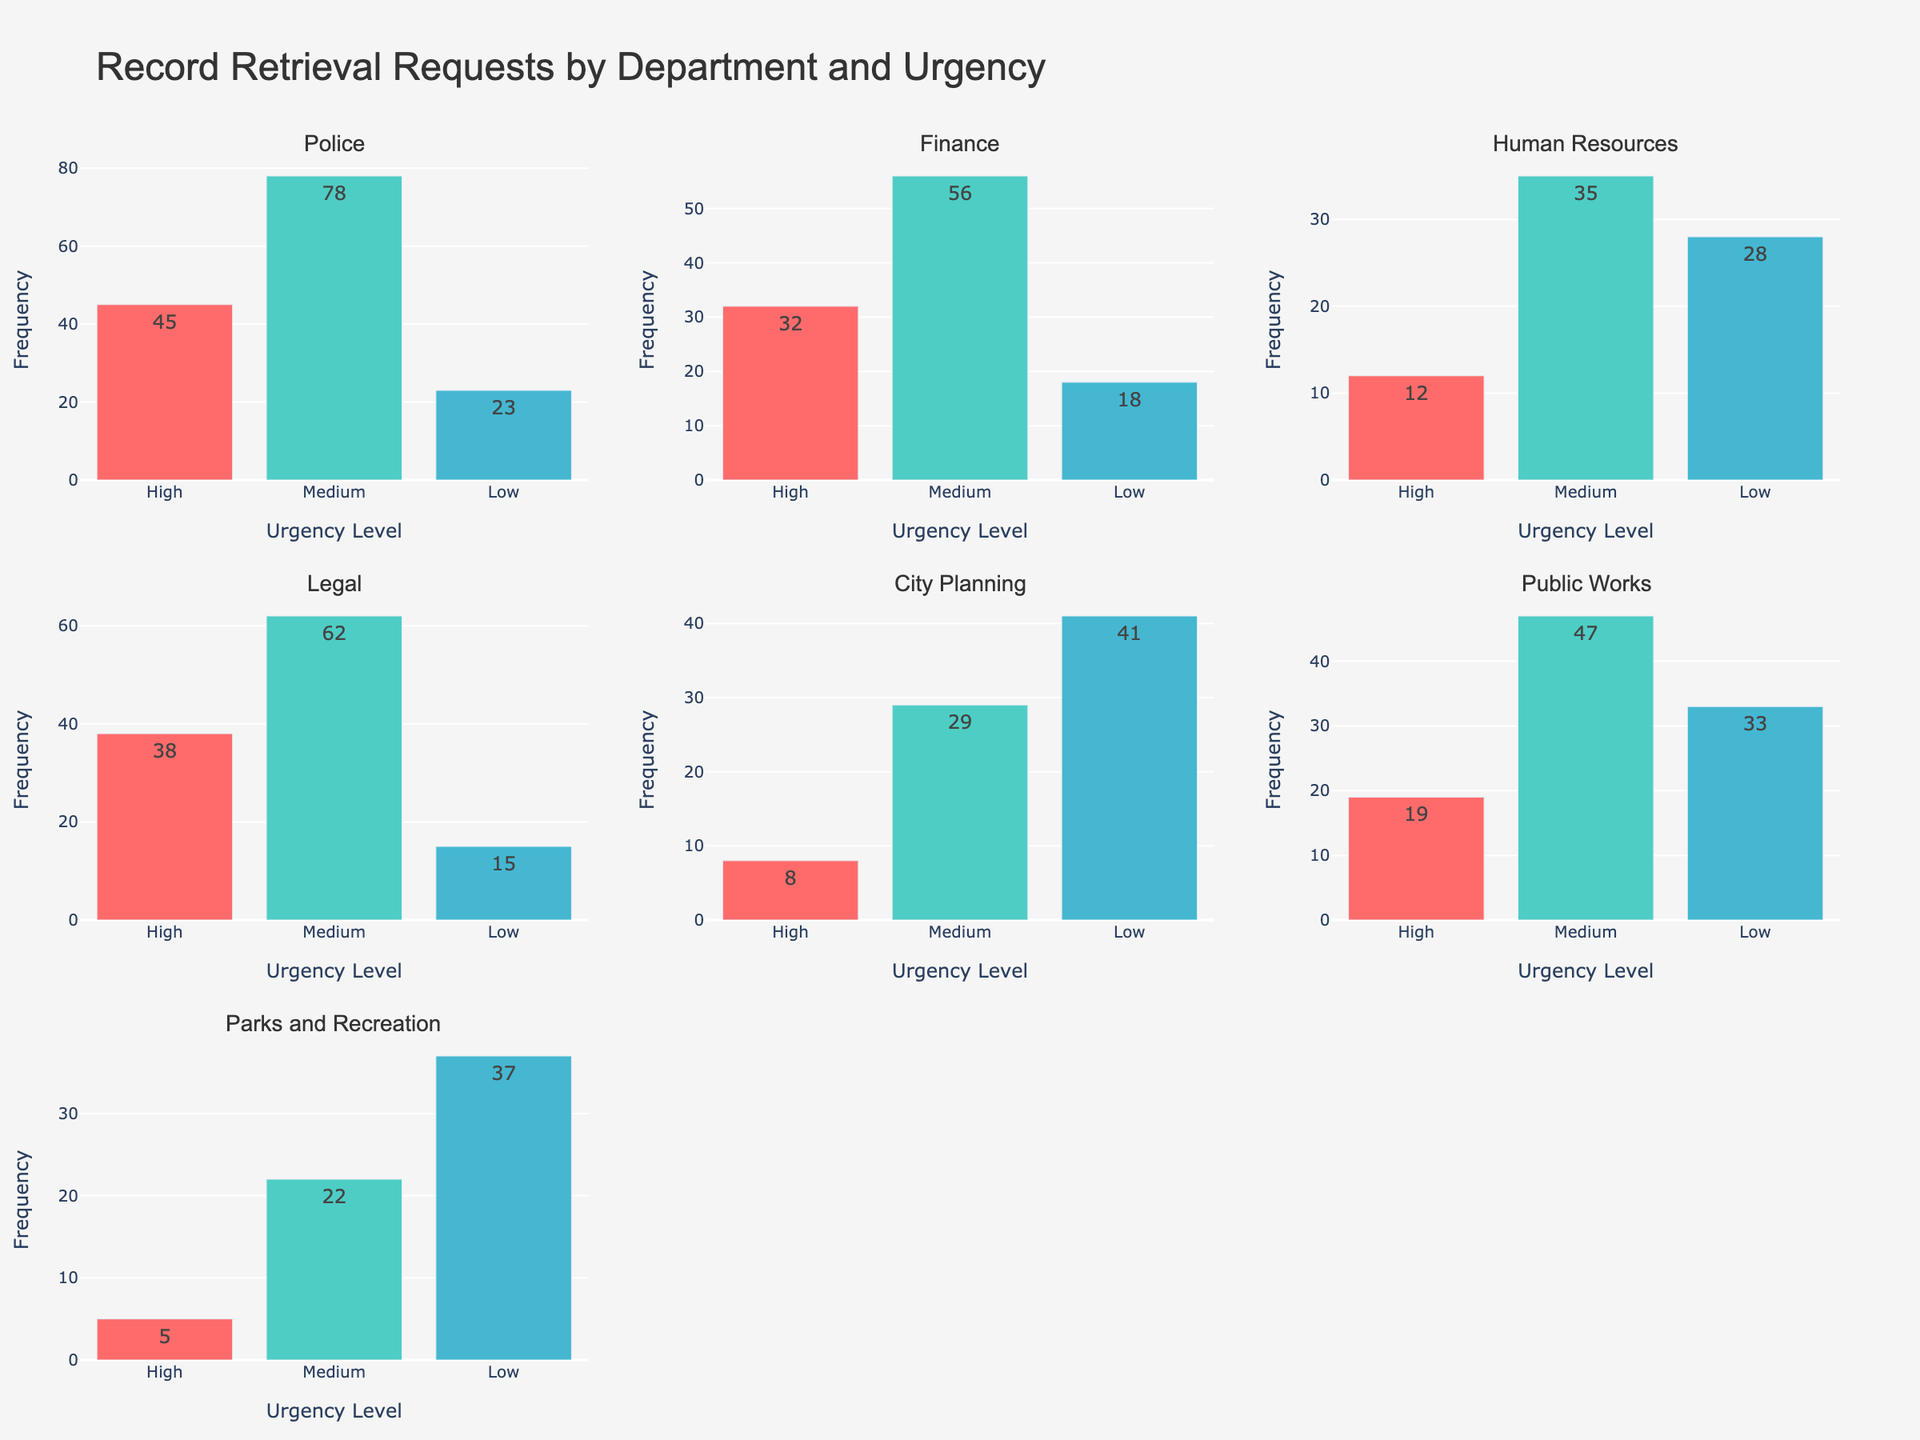Which department has the highest frequency of low urgency record retrieval requests? Look at the subplot for each department and check the bar height for 'Low' urgency requests. Identify the department with the tallest bar for low urgency.
Answer: City Planning What is the total frequency of high urgency requests across all departments? Add the frequency values of 'High' urgency requests from all subplots. 45 (Police) + 32 (Finance) + 12 (Human Resources) + 38 (Legal) + 8 (City Planning) + 19 (Public Works) + 5 (Parks and Recreation) = 159
Answer: 159 Which department had the least number of record retrieval requests across all urgency levels? Sum the frequency values for all urgency levels within each department and compare. Parks and Recreation: 5+22+37=64 is the lowest total compared to others.
Answer: Parks and Recreation How many departments have a medium urgency frequency greater than 50? Check the 'Medium' urgency bar height for each subplot and count how many are above 50. Police, Finance, Legal, Public Works meet this criterion.
Answer: 4 Are there any departments where low urgency requests are higher than medium urgency requests? Check each subplot to compare 'Low' urgency and 'Medium' urgency bars. Only City Planning has 'Low' (41) higher than 'Medium' (29).
Answer: Yes What is the average frequency of record retrieval requests for medium urgency across all departments? Sum the 'Medium' urgency frequencies and divide by the number of departments: (78+56+35+62+29+47+22)/7 = 329/7 = 47
Answer: 47 Which urgency level has the most even distribution across all departments? Compare the variation across subplots for each urgency level. 'Medium' appears to have more consistent values across departments compared to 'High' and 'Low'.
Answer: Medium What is the combined frequency of low urgency requests from Legal, Public Works, and Parks and Recreation? Add the 'Low' urgency request frequencies for these specific departments: 15 (Legal) + 33 (Public Works) + 37 (Parks and Recreation) = 85
Answer: 85 